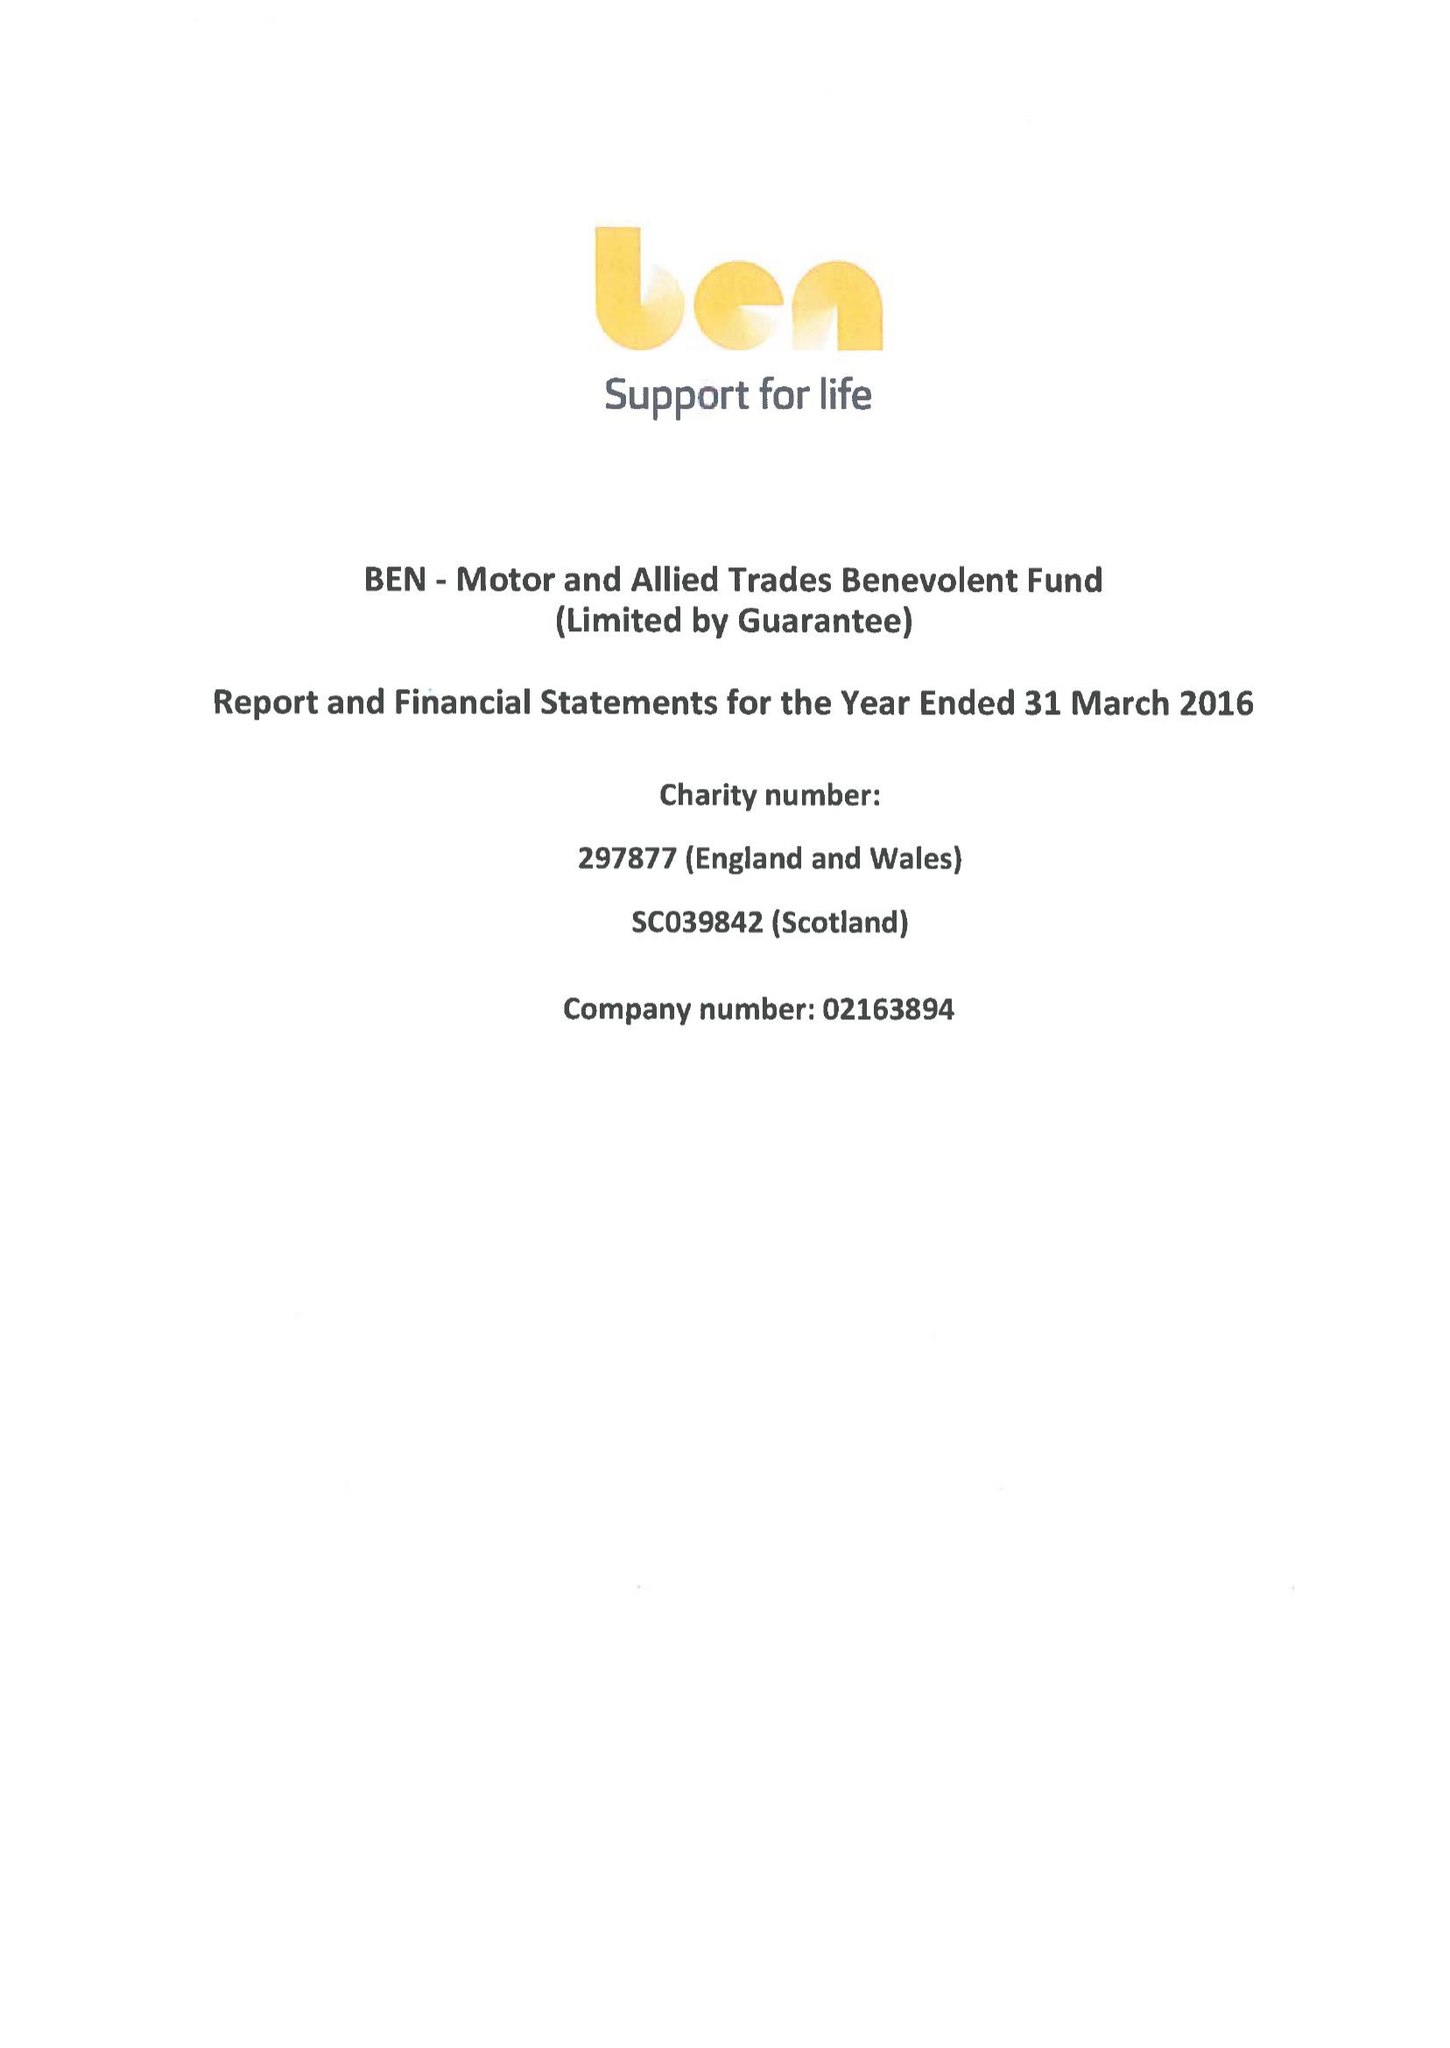What is the value for the report_date?
Answer the question using a single word or phrase. 2016-03-31 